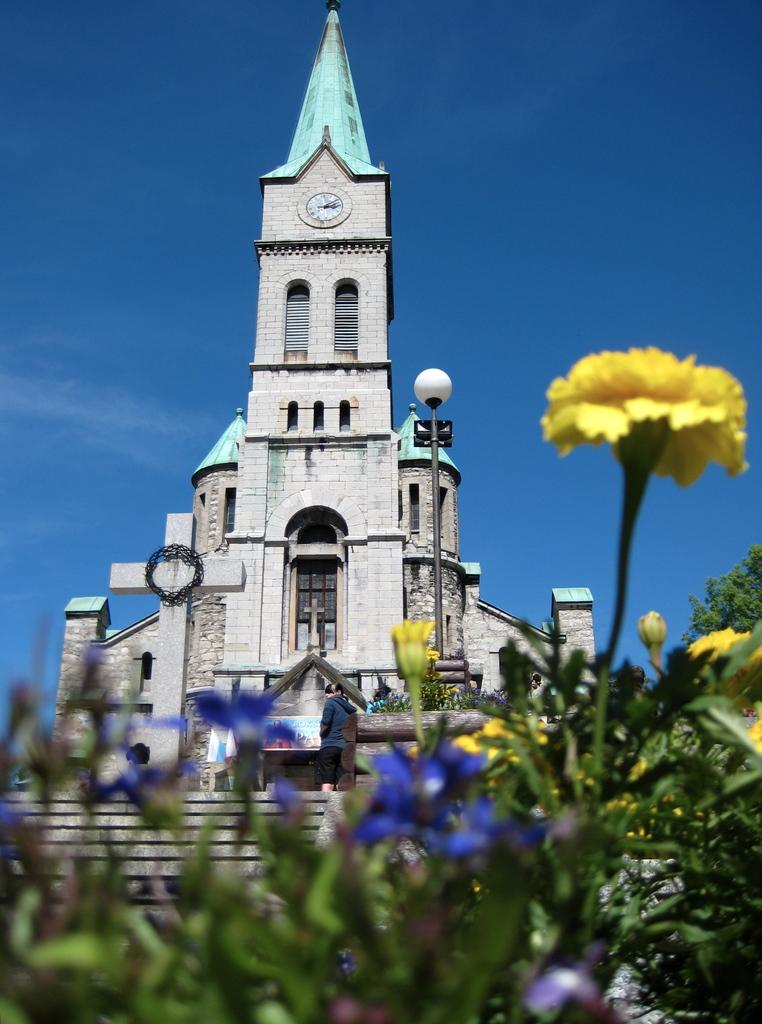What types of flowers can be seen in the image? There are yellow and blue flowers in the image. What can be seen in the background of the image? There is a church, a pole, a bulb on the pole, and the sky visible in the background of the image. What type of rhythm can be heard coming from the church in the image? There is no indication in the image that any sound, including rhythm, is coming from the church. 